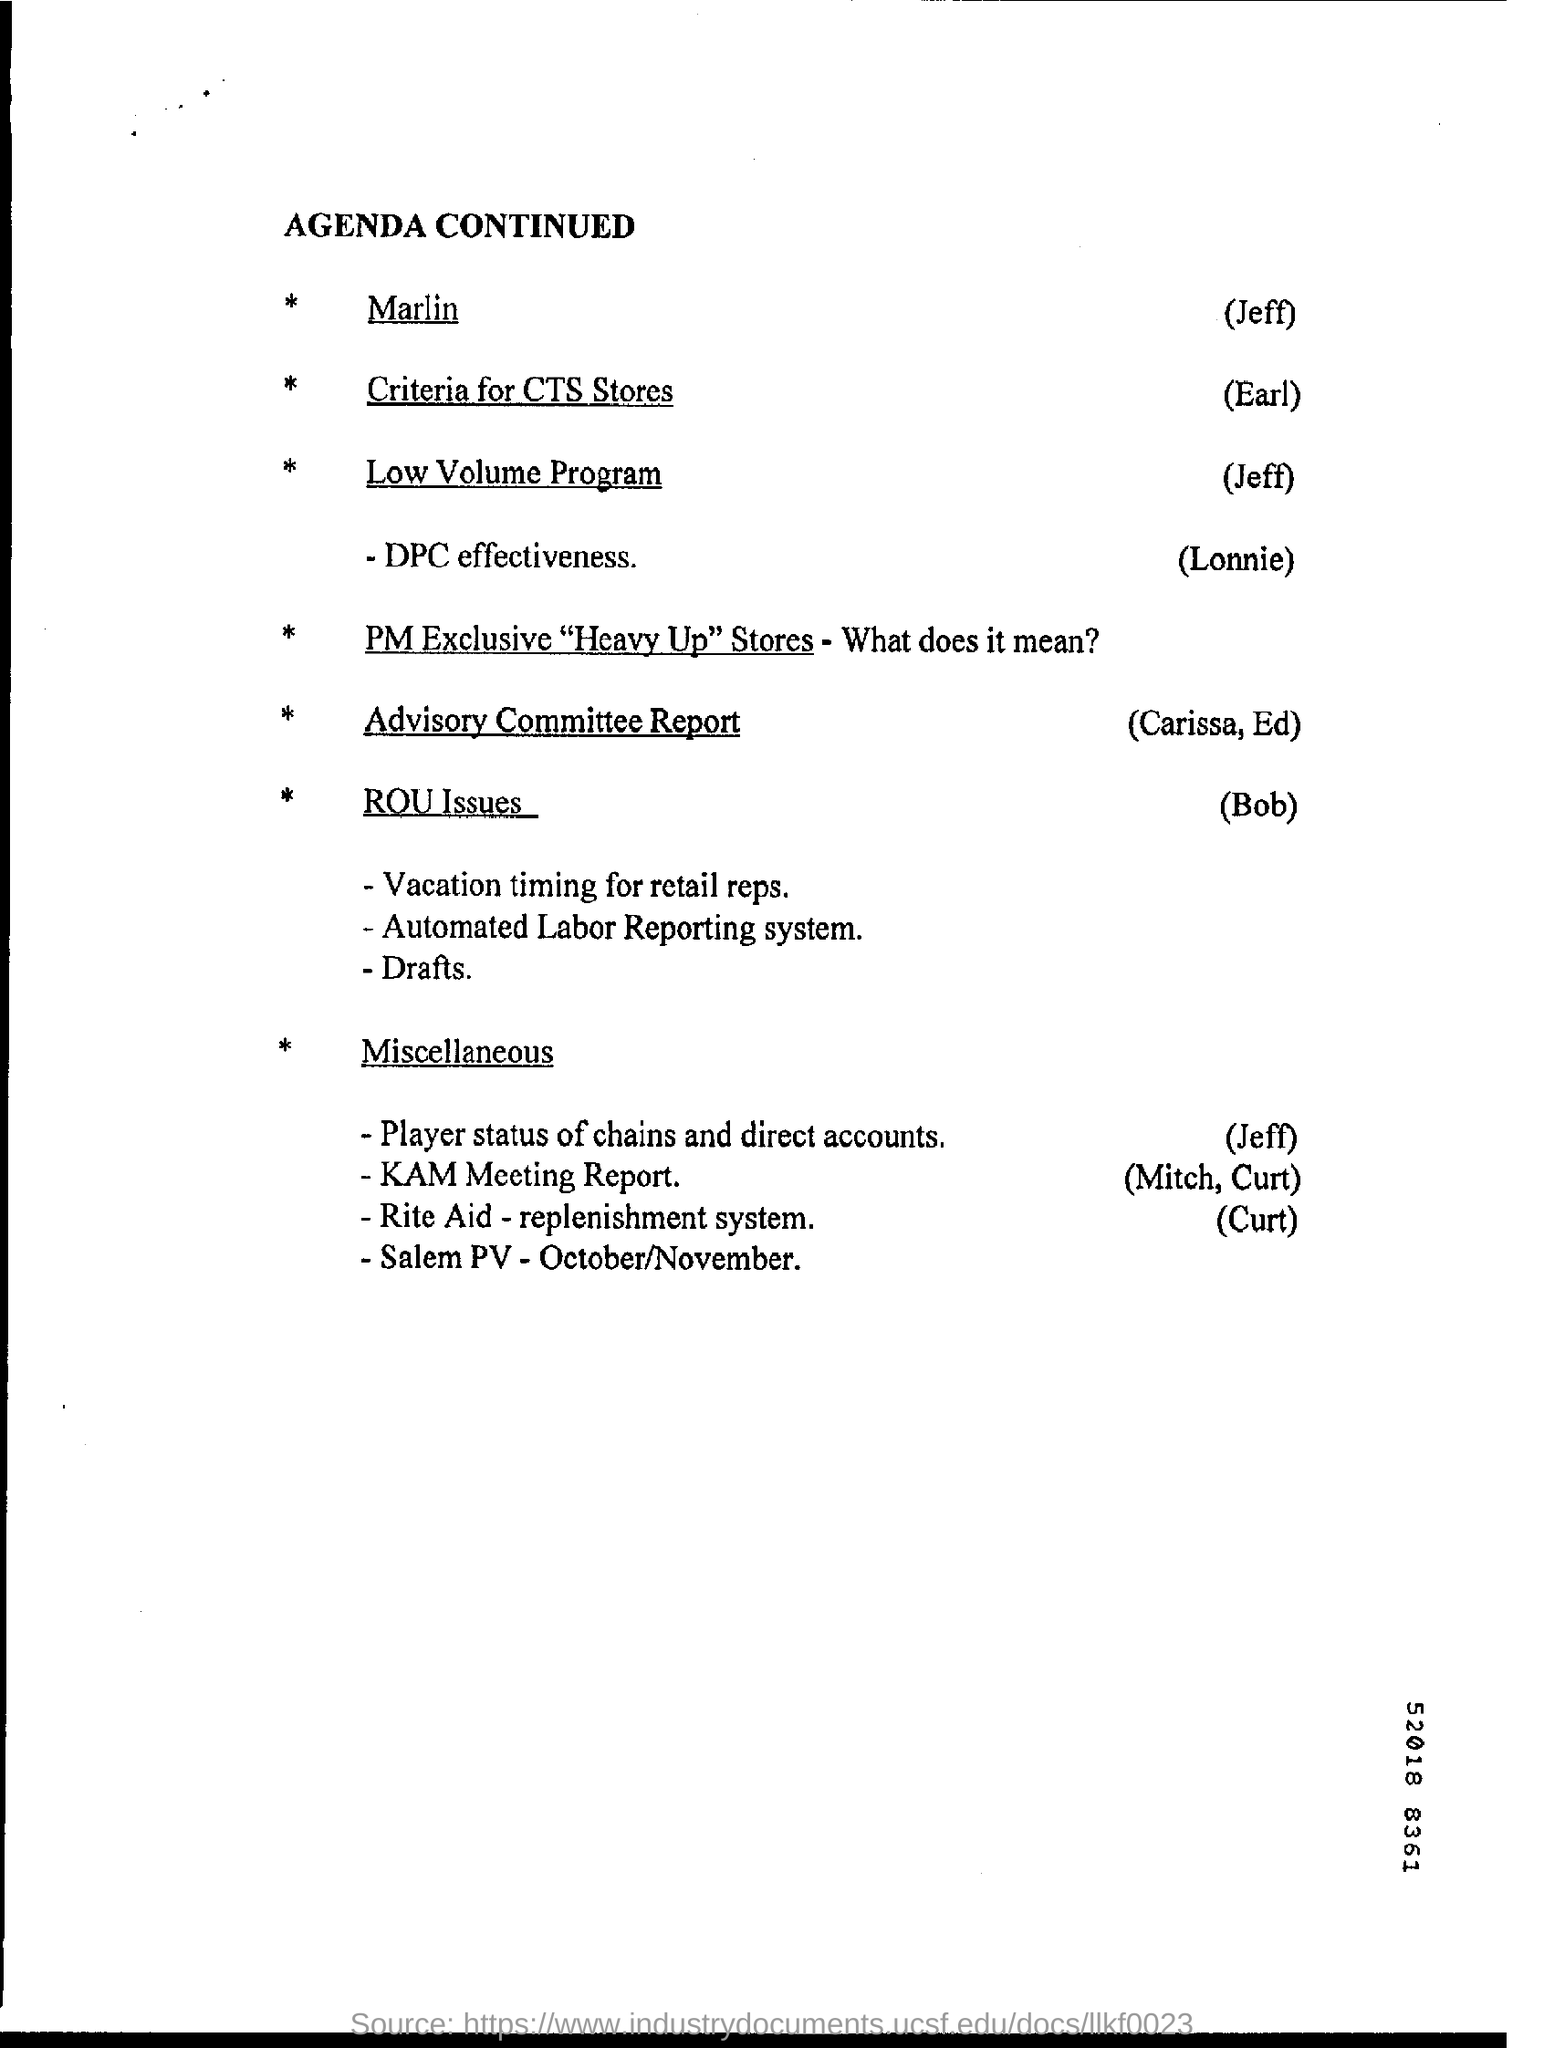Identify some key points in this picture. The heading of the page is "Agenda Continued..". 